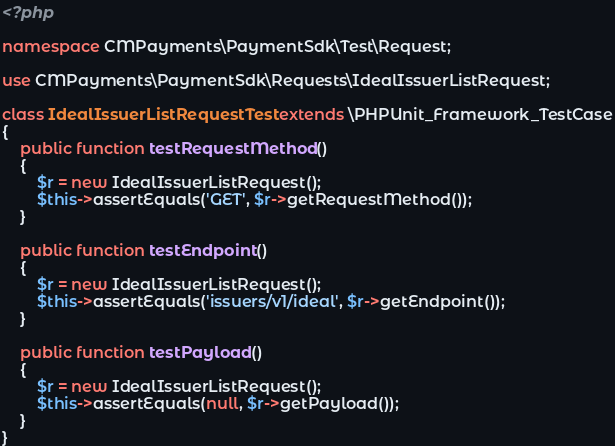Convert code to text. <code><loc_0><loc_0><loc_500><loc_500><_PHP_><?php

namespace CMPayments\PaymentSdk\Test\Request;

use CMPayments\PaymentSdk\Requests\IdealIssuerListRequest;

class IdealIssuerListRequestTest extends \PHPUnit_Framework_TestCase
{
    public function testRequestMethod()
    {
        $r = new IdealIssuerListRequest();
        $this->assertEquals('GET', $r->getRequestMethod());
    }

    public function testEndpoint()
    {
        $r = new IdealIssuerListRequest();
        $this->assertEquals('issuers/v1/ideal', $r->getEndpoint());
    }

    public function testPayload()
    {
        $r = new IdealIssuerListRequest();
        $this->assertEquals(null, $r->getPayload());
    }
}
</code> 